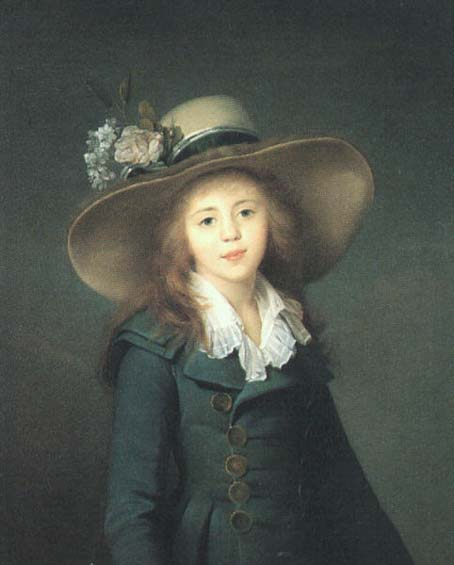What might the choice of flowers in the hat signify about the subject's social status or personal tastes? The flowers in the hat are likely chosen to symbolize delicacy and grace, common traits valued in the portrayed era for young women of a higher social standing. The variety and freshness of the blooms could also suggest her family’s wealth and high regard for fashion and personal grooming typical of aristocratic circles of the time. 